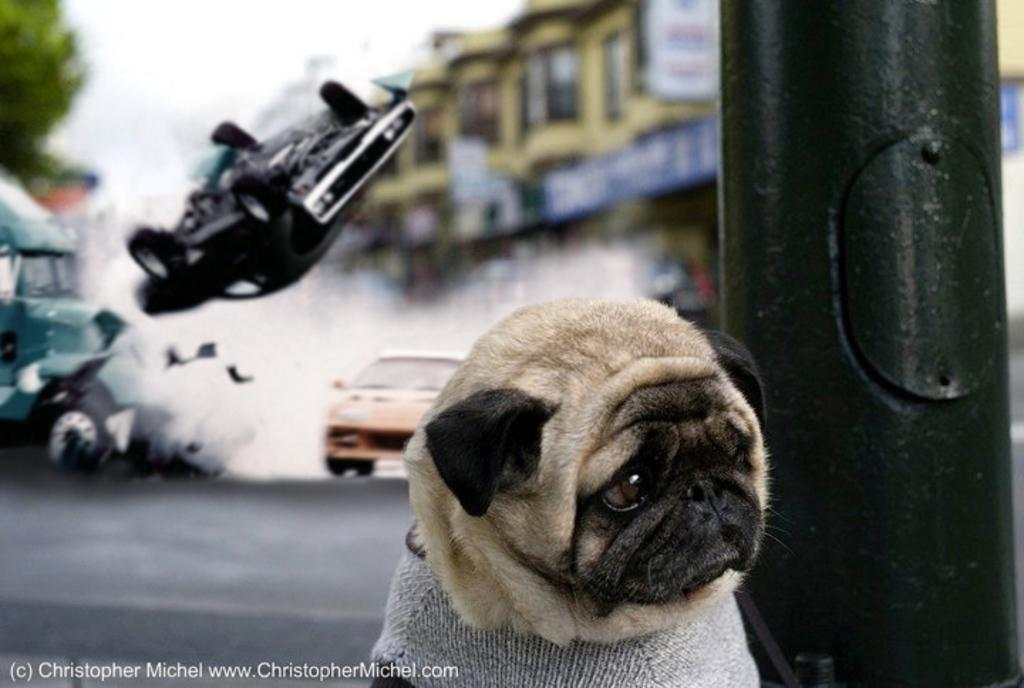What animal is near a pillar in the image? There is a dog near a pillar in the image. What types of man-made structures can be seen in the image? There are vehicles and buildings in the image. What can be seen in the background of the image? There are trees and the sky visible in the background of the image. What type of pot is being used to water the trees in the image? There is no pot or watering activity present in the image. 